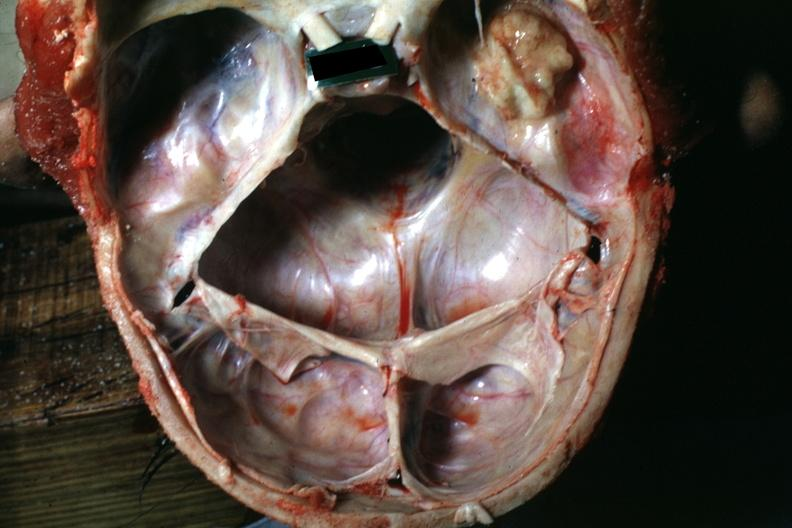s embryo-fetus present?
Answer the question using a single word or phrase. No 